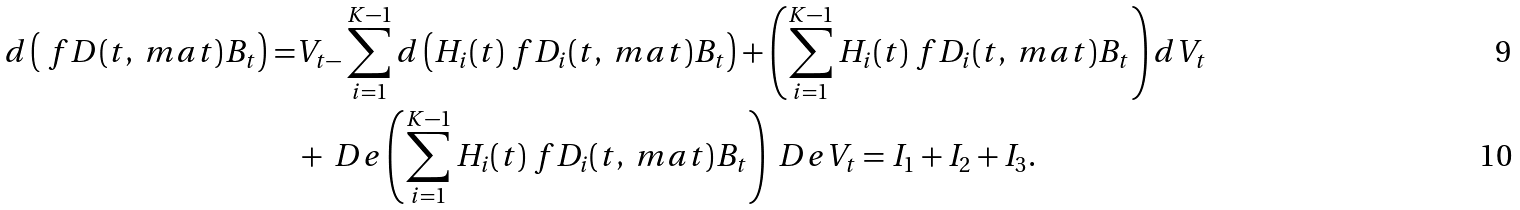<formula> <loc_0><loc_0><loc_500><loc_500>d \left ( \ f { D ( t , \ m a t ) } { B _ { t } } \right ) = & V _ { t - } \sum _ { i = 1 } ^ { K - 1 } d \left ( H _ { i } ( t ) \ f { D _ { i } ( t , \ m a t ) } { B _ { t } } \right ) + \left ( \sum _ { i = 1 } ^ { K - 1 } H _ { i } ( t ) \ f { D _ { i } ( t , \ m a t ) } { B _ { t } } \right ) d V _ { t } \\ & + \ D e \left ( \sum _ { i = 1 } ^ { K - 1 } H _ { i } ( t ) \ f { D _ { i } ( t , \ m a t ) } { B _ { t } } \right ) \ D e V _ { t } = I _ { 1 } + I _ { 2 } + I _ { 3 } .</formula> 